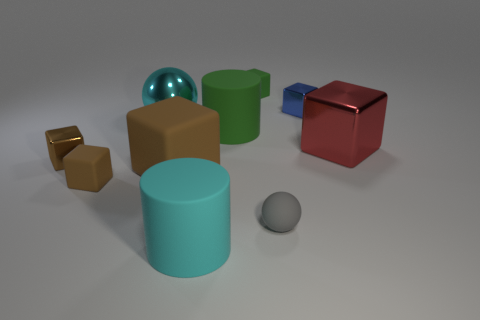What is the shape of the small brown thing that is in front of the brown shiny object?
Make the answer very short. Cube. How many other objects are the same shape as the big red metallic thing?
Provide a short and direct response. 5. Is the big cyan object that is behind the big cyan rubber object made of the same material as the tiny sphere?
Offer a very short reply. No. Is the number of green cylinders that are in front of the gray sphere the same as the number of big rubber objects that are on the left side of the blue shiny cube?
Offer a terse response. No. How big is the metallic block to the left of the green cylinder?
Offer a very short reply. Small. Is there another thing that has the same material as the blue thing?
Offer a very short reply. Yes. There is a large metal thing on the left side of the green cube; is it the same color as the big rubber block?
Your response must be concise. No. Are there an equal number of rubber cylinders that are left of the green matte cylinder and cyan things?
Ensure brevity in your answer.  No. Is there a small metallic object that has the same color as the large matte cube?
Provide a succinct answer. Yes. Do the red metallic object and the gray object have the same size?
Keep it short and to the point. No. 